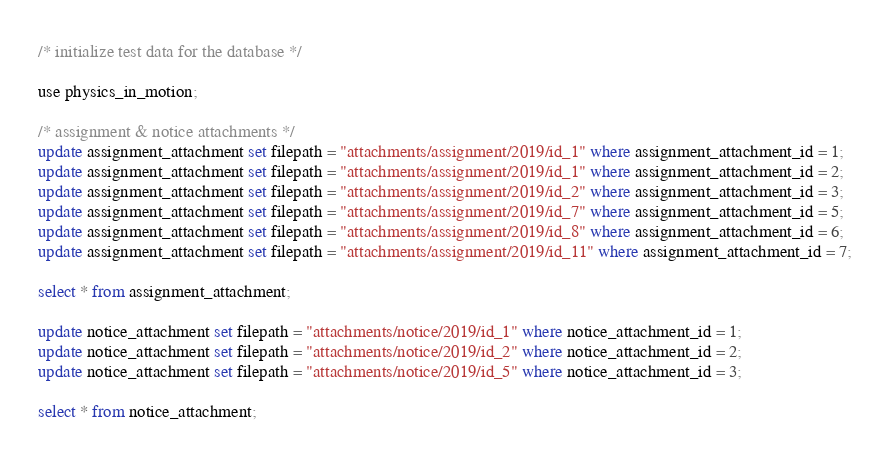Convert code to text. <code><loc_0><loc_0><loc_500><loc_500><_SQL_>/* initialize test data for the database */

use physics_in_motion;

/* assignment & notice attachments */
update assignment_attachment set filepath = "attachments/assignment/2019/id_1" where assignment_attachment_id = 1;
update assignment_attachment set filepath = "attachments/assignment/2019/id_1" where assignment_attachment_id = 2;
update assignment_attachment set filepath = "attachments/assignment/2019/id_2" where assignment_attachment_id = 3;
update assignment_attachment set filepath = "attachments/assignment/2019/id_7" where assignment_attachment_id = 5;
update assignment_attachment set filepath = "attachments/assignment/2019/id_8" where assignment_attachment_id = 6;
update assignment_attachment set filepath = "attachments/assignment/2019/id_11" where assignment_attachment_id = 7;

select * from assignment_attachment;

update notice_attachment set filepath = "attachments/notice/2019/id_1" where notice_attachment_id = 1;
update notice_attachment set filepath = "attachments/notice/2019/id_2" where notice_attachment_id = 2;
update notice_attachment set filepath = "attachments/notice/2019/id_5" where notice_attachment_id = 3;

select * from notice_attachment;
</code> 